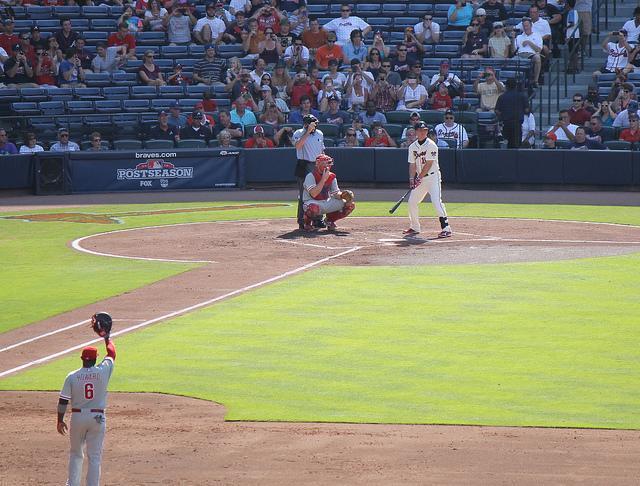How many people are there?
Give a very brief answer. 4. 